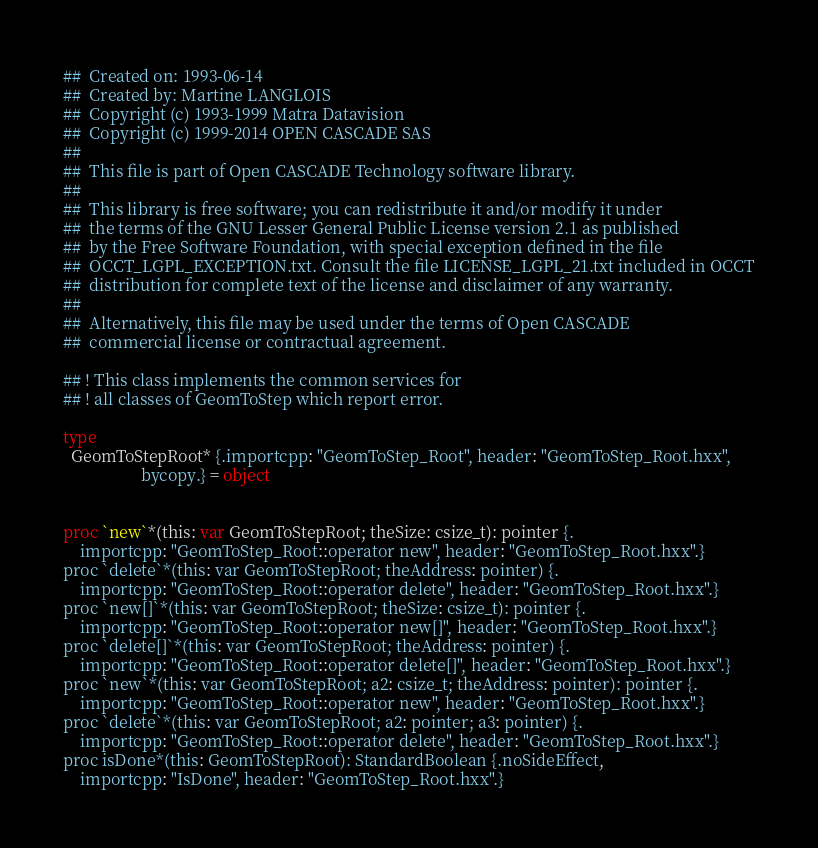Convert code to text. <code><loc_0><loc_0><loc_500><loc_500><_Nim_>##  Created on: 1993-06-14
##  Created by: Martine LANGLOIS
##  Copyright (c) 1993-1999 Matra Datavision
##  Copyright (c) 1999-2014 OPEN CASCADE SAS
##
##  This file is part of Open CASCADE Technology software library.
##
##  This library is free software; you can redistribute it and/or modify it under
##  the terms of the GNU Lesser General Public License version 2.1 as published
##  by the Free Software Foundation, with special exception defined in the file
##  OCCT_LGPL_EXCEPTION.txt. Consult the file LICENSE_LGPL_21.txt included in OCCT
##  distribution for complete text of the license and disclaimer of any warranty.
##
##  Alternatively, this file may be used under the terms of Open CASCADE
##  commercial license or contractual agreement.

## ! This class implements the common services for
## ! all classes of GeomToStep which report error.

type
  GeomToStepRoot* {.importcpp: "GeomToStep_Root", header: "GeomToStep_Root.hxx",
                   bycopy.} = object


proc `new`*(this: var GeomToStepRoot; theSize: csize_t): pointer {.
    importcpp: "GeomToStep_Root::operator new", header: "GeomToStep_Root.hxx".}
proc `delete`*(this: var GeomToStepRoot; theAddress: pointer) {.
    importcpp: "GeomToStep_Root::operator delete", header: "GeomToStep_Root.hxx".}
proc `new[]`*(this: var GeomToStepRoot; theSize: csize_t): pointer {.
    importcpp: "GeomToStep_Root::operator new[]", header: "GeomToStep_Root.hxx".}
proc `delete[]`*(this: var GeomToStepRoot; theAddress: pointer) {.
    importcpp: "GeomToStep_Root::operator delete[]", header: "GeomToStep_Root.hxx".}
proc `new`*(this: var GeomToStepRoot; a2: csize_t; theAddress: pointer): pointer {.
    importcpp: "GeomToStep_Root::operator new", header: "GeomToStep_Root.hxx".}
proc `delete`*(this: var GeomToStepRoot; a2: pointer; a3: pointer) {.
    importcpp: "GeomToStep_Root::operator delete", header: "GeomToStep_Root.hxx".}
proc isDone*(this: GeomToStepRoot): StandardBoolean {.noSideEffect,
    importcpp: "IsDone", header: "GeomToStep_Root.hxx".}</code> 